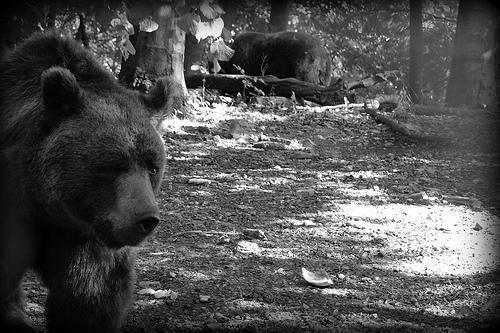How many bears are in the photo?
Give a very brief answer. 2. 